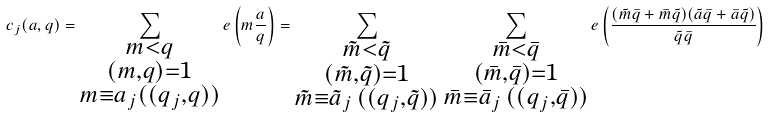<formula> <loc_0><loc_0><loc_500><loc_500>c _ { j } ( a , q ) = \sum _ { \substack { m < q \\ ( m , q ) = 1 \\ m \equiv a _ { j } ( ( q _ { j } , q ) ) } } e \left ( m \frac { a } { q } \right ) = \sum _ { \substack { \tilde { m } < \tilde { q } \\ ( \tilde { m } , \tilde { q } ) = 1 \\ \tilde { m } \equiv \tilde { a } _ { j } \, ( ( q _ { j } , \tilde { q } ) ) } } \, \sum _ { \substack { \bar { m } < \bar { q } \\ ( \bar { m } , \bar { q } ) = 1 \\ \bar { m } \equiv \bar { a } _ { j } \, ( ( q _ { j } , \bar { q } ) ) } } e \left ( \frac { ( \tilde { m } \bar { q } + \bar { m } \tilde { q } ) ( \tilde { a } \bar { q } + \bar { a } \tilde { q } ) } { \tilde { q } \bar { q } } \right )</formula> 